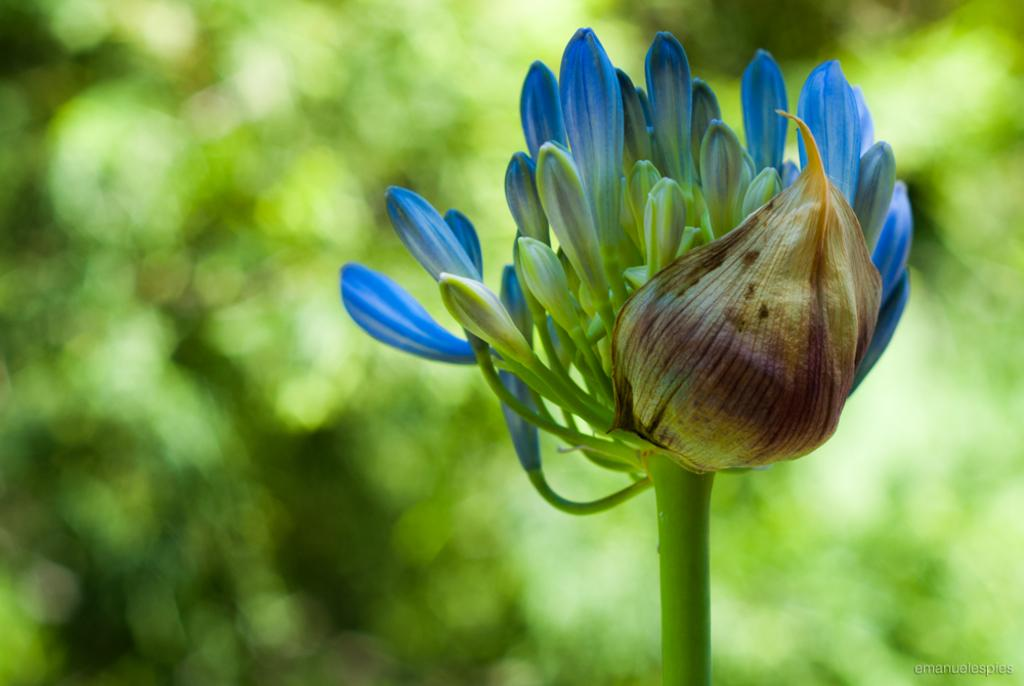What type of flower is in the image? There is a purple and green color flower in the image. What color is the background of the image? The background of the image is green. How does the flower wash its hands in the image? The flower does not have hands to wash, as it is a non-living object. 